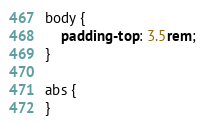Convert code to text. <code><loc_0><loc_0><loc_500><loc_500><_CSS_>body {
    padding-top: 3.5rem;
}

abs {
}</code> 